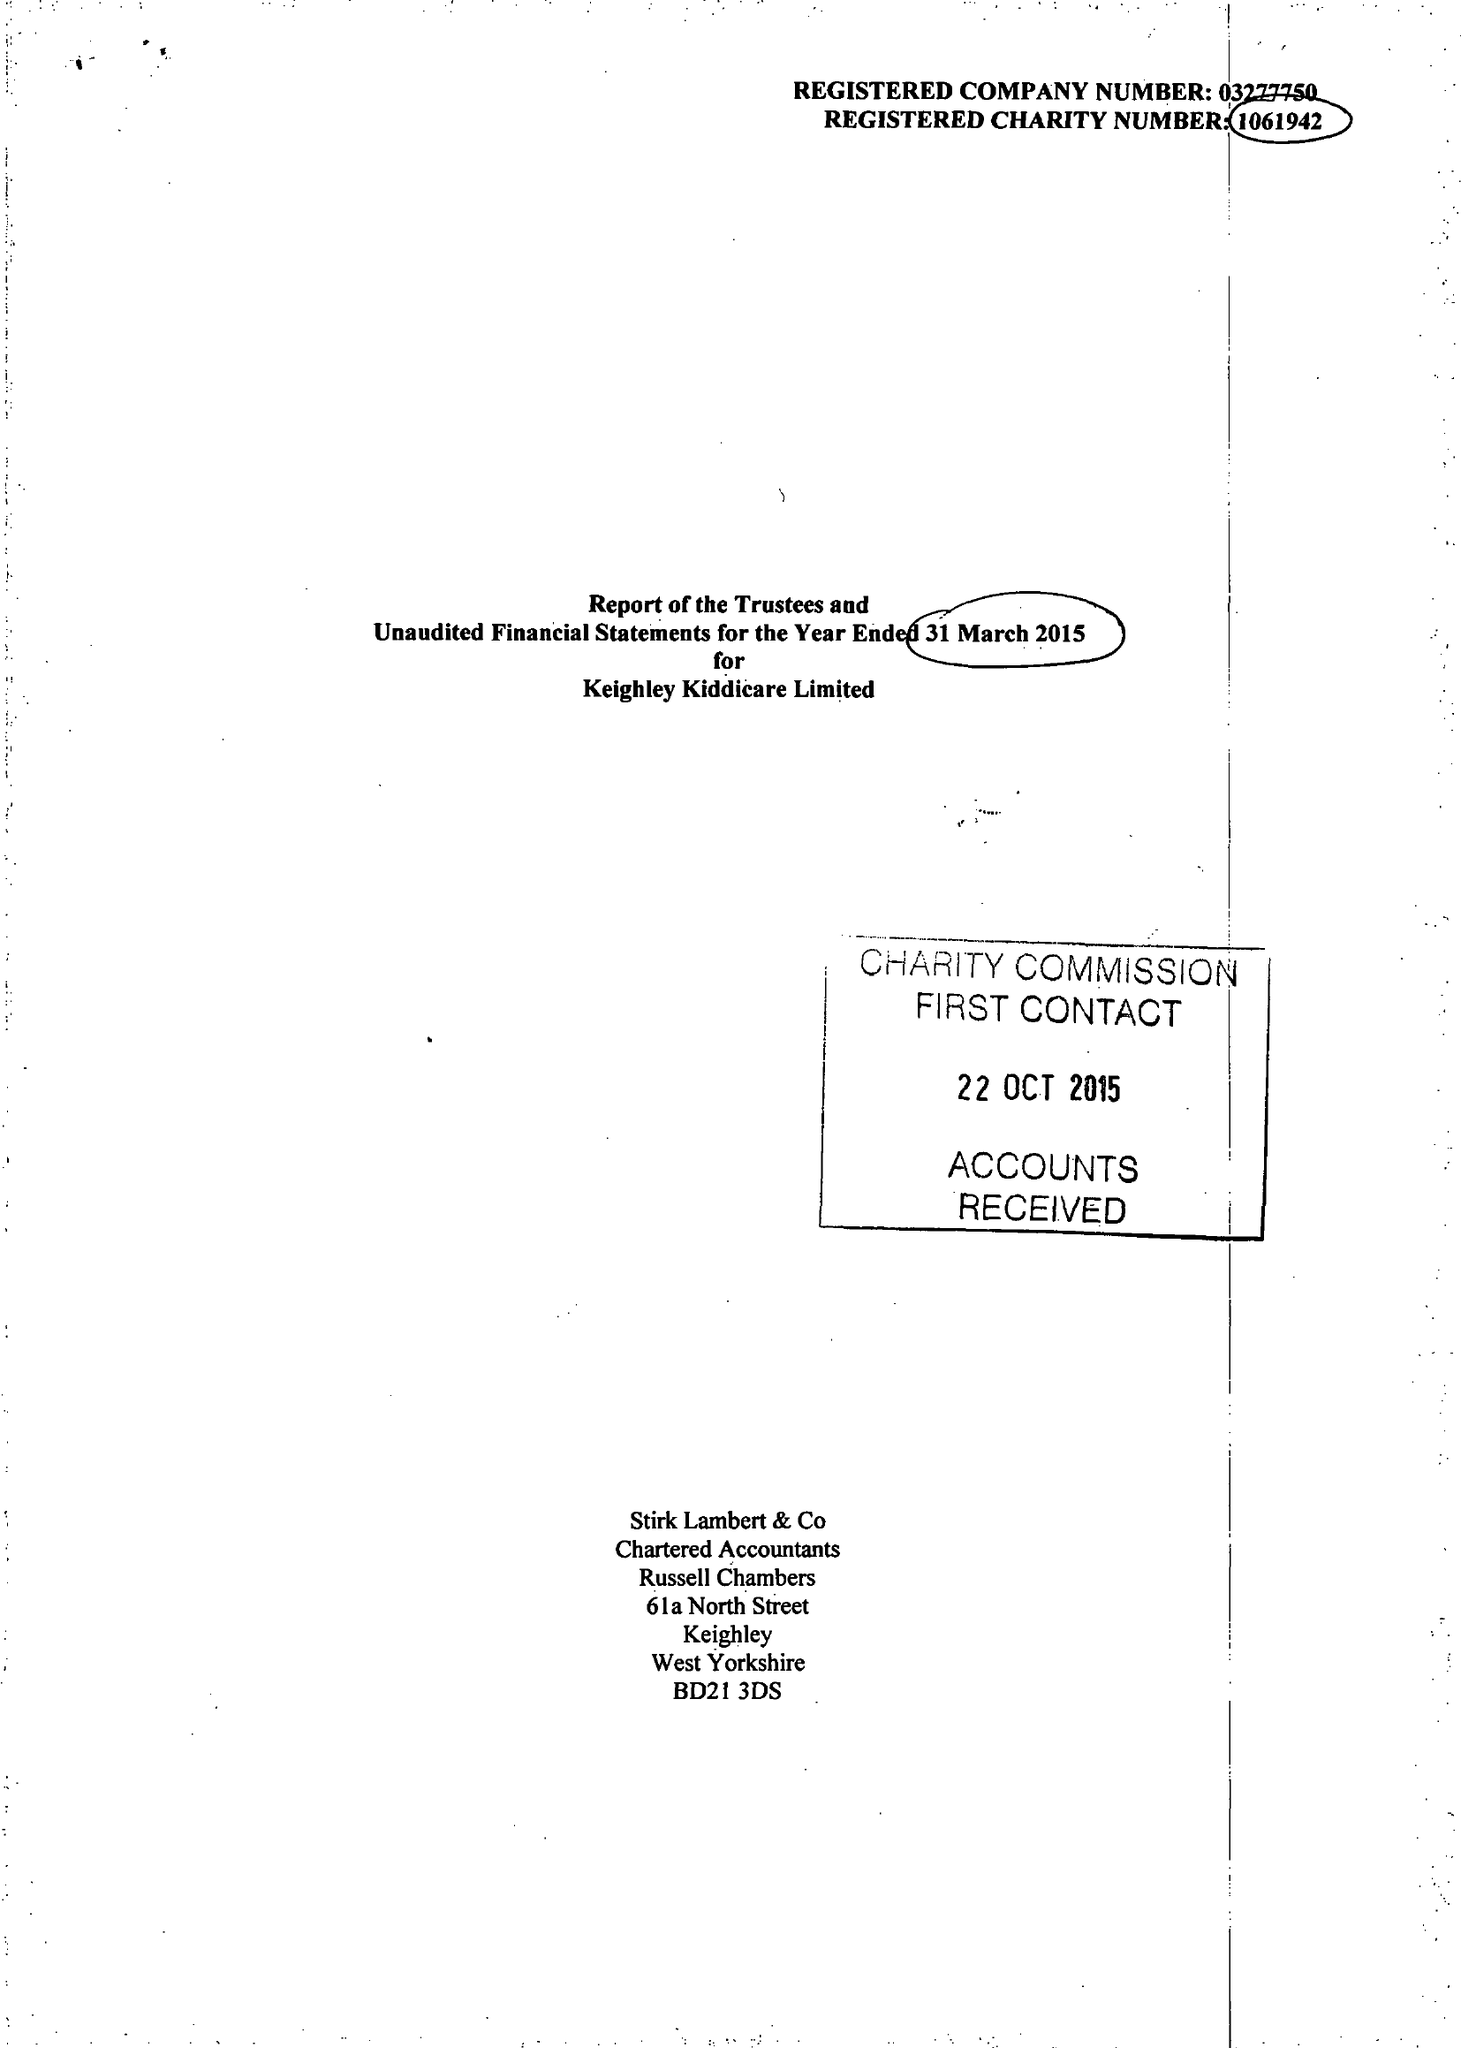What is the value for the address__post_town?
Answer the question using a single word or phrase. KEIGHLEY 